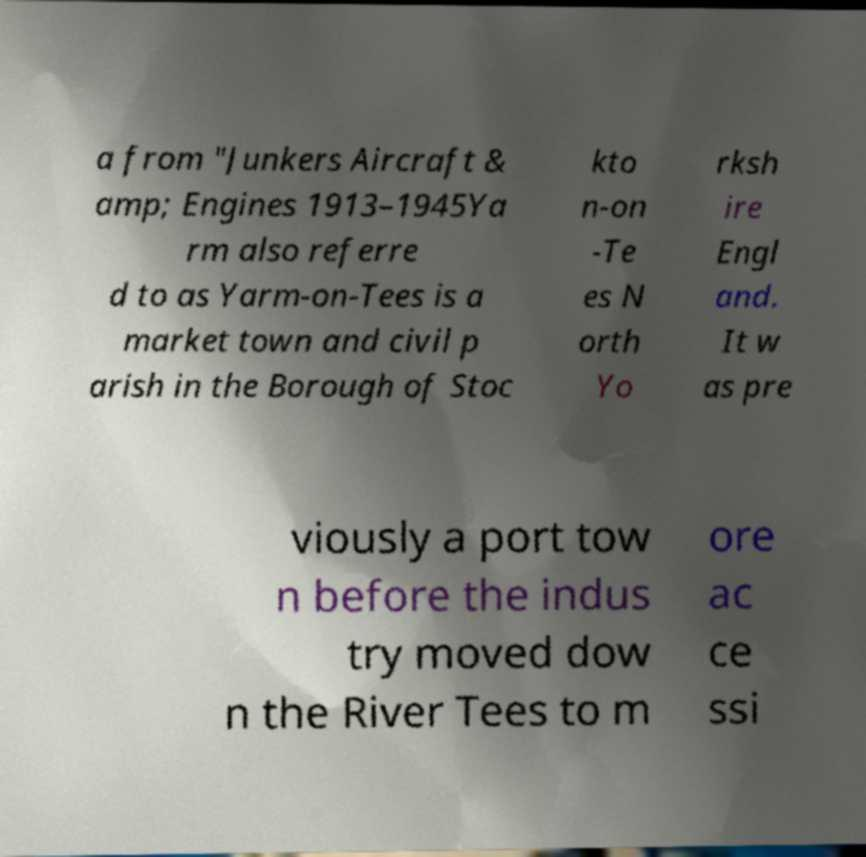Can you read and provide the text displayed in the image?This photo seems to have some interesting text. Can you extract and type it out for me? a from "Junkers Aircraft & amp; Engines 1913–1945Ya rm also referre d to as Yarm-on-Tees is a market town and civil p arish in the Borough of Stoc kto n-on -Te es N orth Yo rksh ire Engl and. It w as pre viously a port tow n before the indus try moved dow n the River Tees to m ore ac ce ssi 